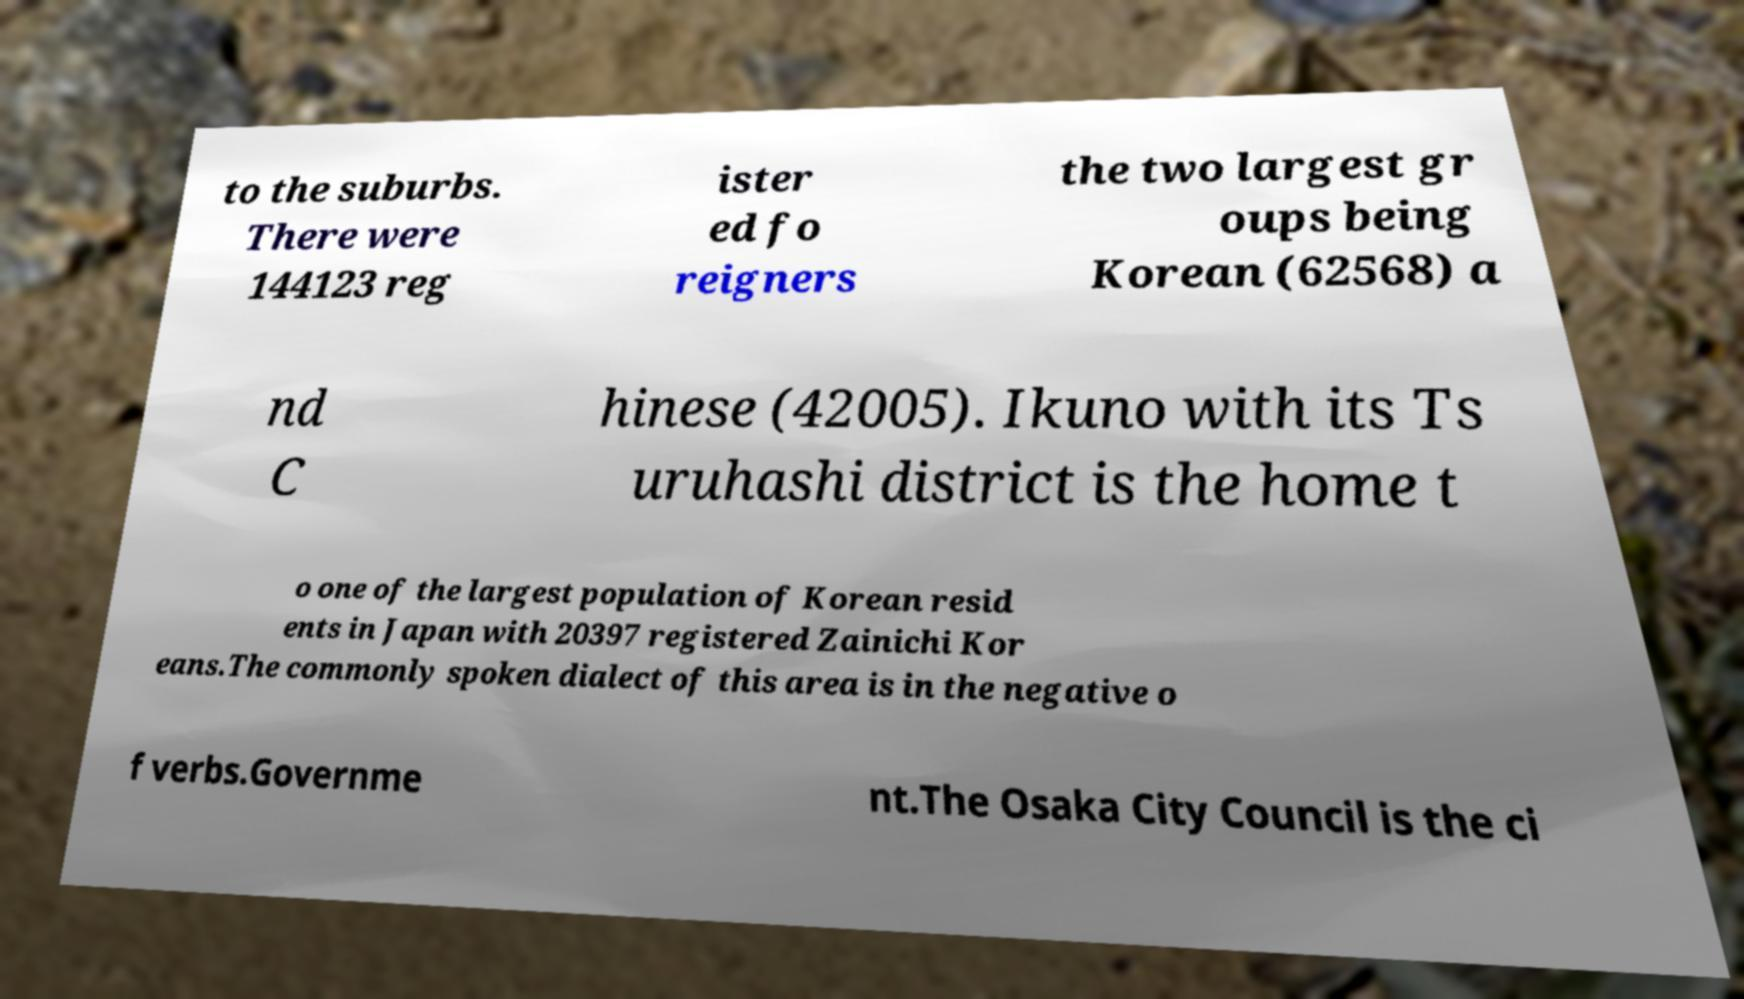Can you read and provide the text displayed in the image?This photo seems to have some interesting text. Can you extract and type it out for me? to the suburbs. There were 144123 reg ister ed fo reigners the two largest gr oups being Korean (62568) a nd C hinese (42005). Ikuno with its Ts uruhashi district is the home t o one of the largest population of Korean resid ents in Japan with 20397 registered Zainichi Kor eans.The commonly spoken dialect of this area is in the negative o f verbs.Governme nt.The Osaka City Council is the ci 